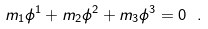<formula> <loc_0><loc_0><loc_500><loc_500>m _ { 1 } \phi ^ { 1 } + m _ { 2 } \phi ^ { 2 } + m _ { 3 } \phi ^ { 3 } = 0 \ .</formula> 